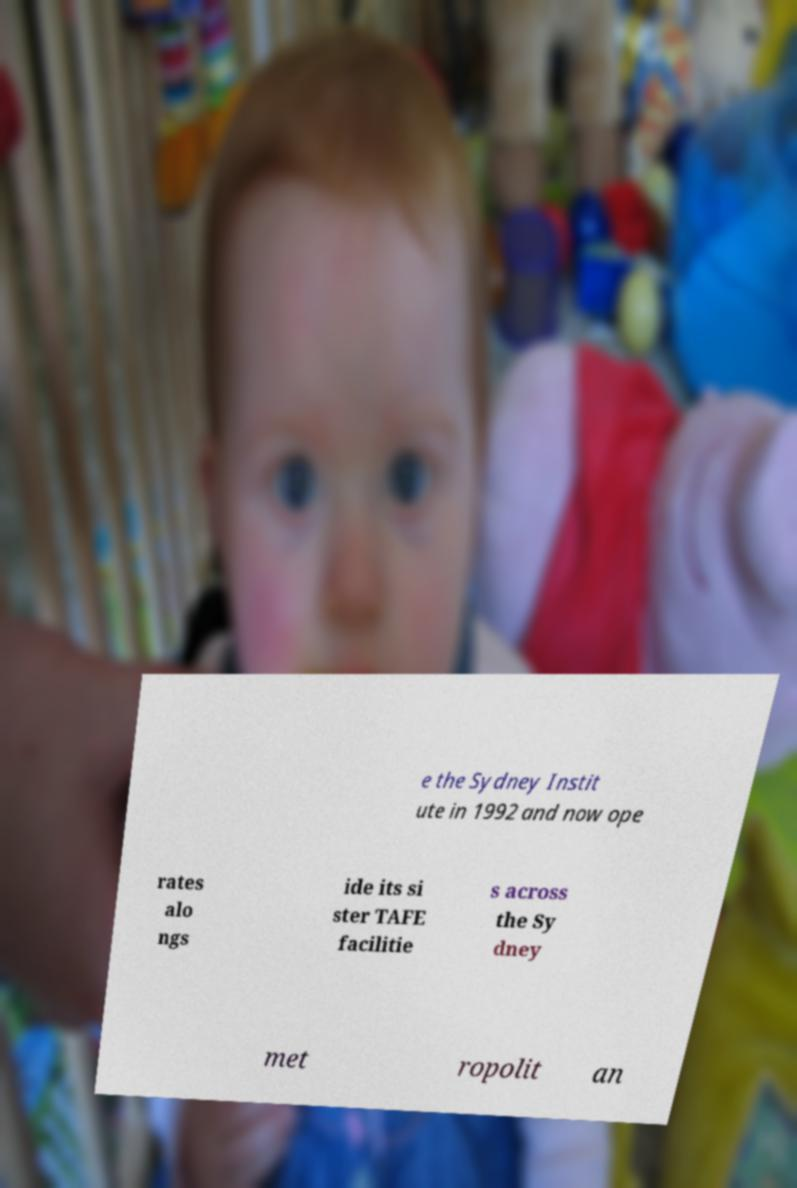For documentation purposes, I need the text within this image transcribed. Could you provide that? e the Sydney Instit ute in 1992 and now ope rates alo ngs ide its si ster TAFE facilitie s across the Sy dney met ropolit an 